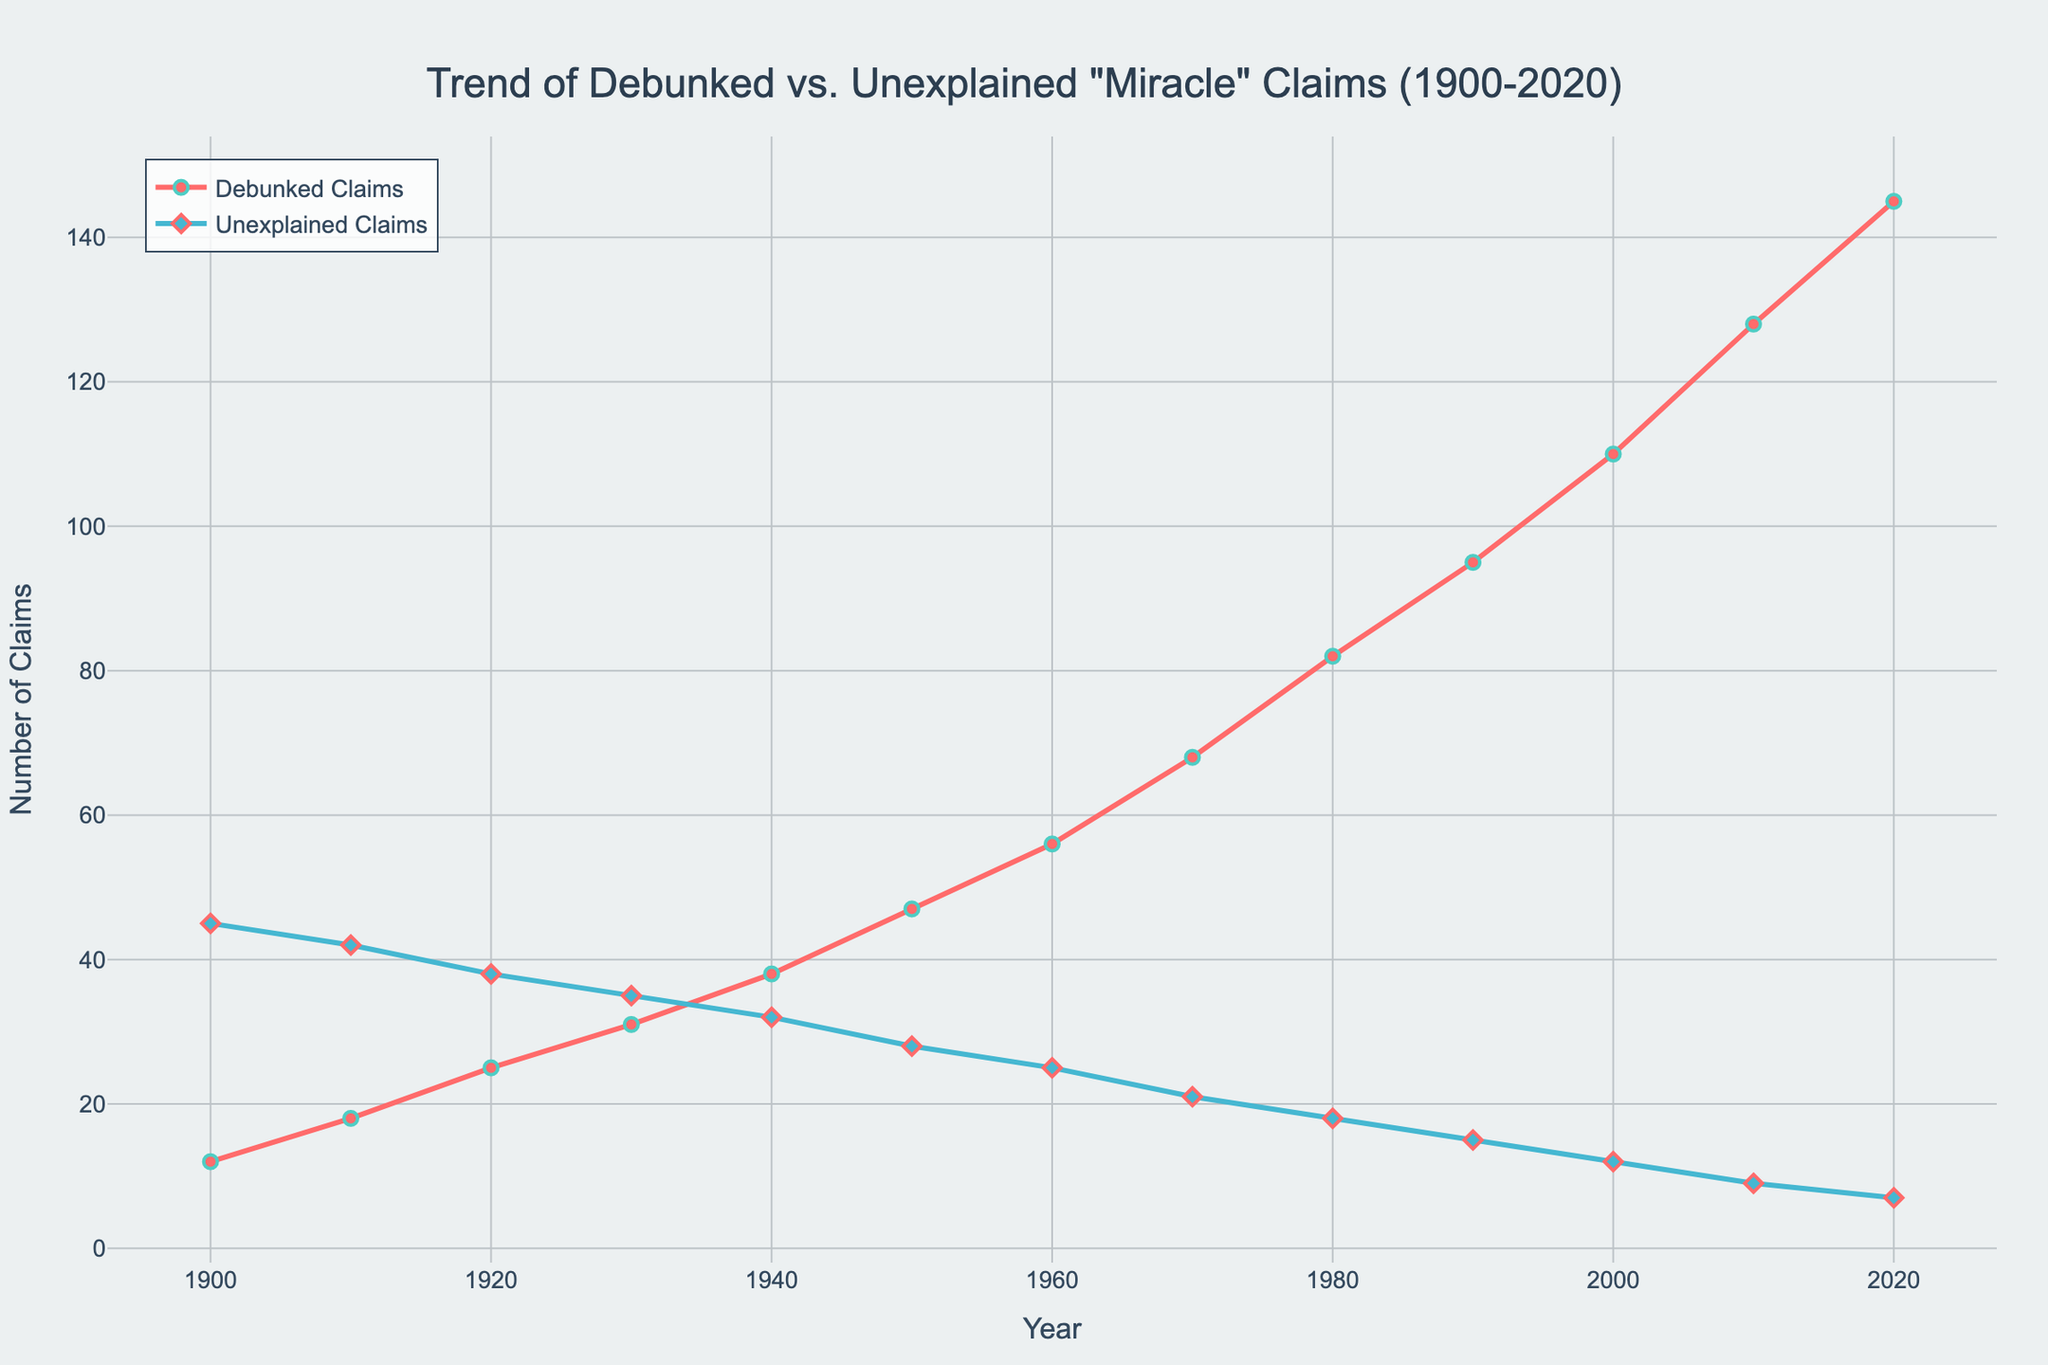What's the trend of debunked claims from 1900 to 2020? The red line representing debunked claims shows a consistent upward trend from 1900 to 2020, indicating that the number of debunked claims increased over time.
Answer: Increasing trend Which year saw the highest number of debunked claims? The highest number of debunked claims, represented by the highest red line point, occurs in 2020 with 145 claims.
Answer: 2020 Which year had the largest gap between debunked and unexplained claims? The year with the largest gap can be identified by finding the largest vertical distance between the red and blue lines. In 2020, the difference between 145 debunked and 7 unexplained claims is 138.
Answer: 2020 How did the number of unexplained claims change from 1900 to 2020? The blue line for unexplained claims shows a decrease from 45 claims in 1900 to 7 claims in 2020. This indicates a downward trend in unexplained claims over time.
Answer: Decreasing trend Which period saw the fastest increase in debunked claims? By analyzing the steepness of the red line, the period between 1970 and 1980 appears to have the fastest increase in debunked claims, rising from 68 to 82 claims.
Answer: 1970-1980 How many more debunked claims were there in 1950 compared to 1900? To find the difference: 47 debunked claims in 1950 minus 12 debunked claims in 1900 equals 35 more claims in 1950.
Answer: 35 In which year did the number of unexplained claims first drop below 10? By examining the blue line and the labels, the unexplained claims first drop below 10 in 2010.
Answer: 2010 Compare the number of debunked and unexplained claims in 1930. Which was greater and by how much? In 1930, there were 31 debunked claims and 35 unexplained claims. The number of unexplained claims exceeds debunked claims by 4.
Answer: Unexplained by 4 What is the average number of debunked claims per decade from 1900 to 2020? To calculate the average: add the debunked claims (12+18+25+31+38+47+56+68+82+95+110+128+145 = 855) and divide by the number of decades (13). The average is approximately 65.8 debunked claims per decade.
Answer: 65.8 How does the trend in unexplained claims compare to the trend in debunked claims over the entire period? The trend in unexplained claims (blue line) shows a consistent decline, while the trend in debunked claims (red line) shows a consistent increase. They exhibit opposite trends over the period from 1900 to 2020.
Answer: Opposite trends 